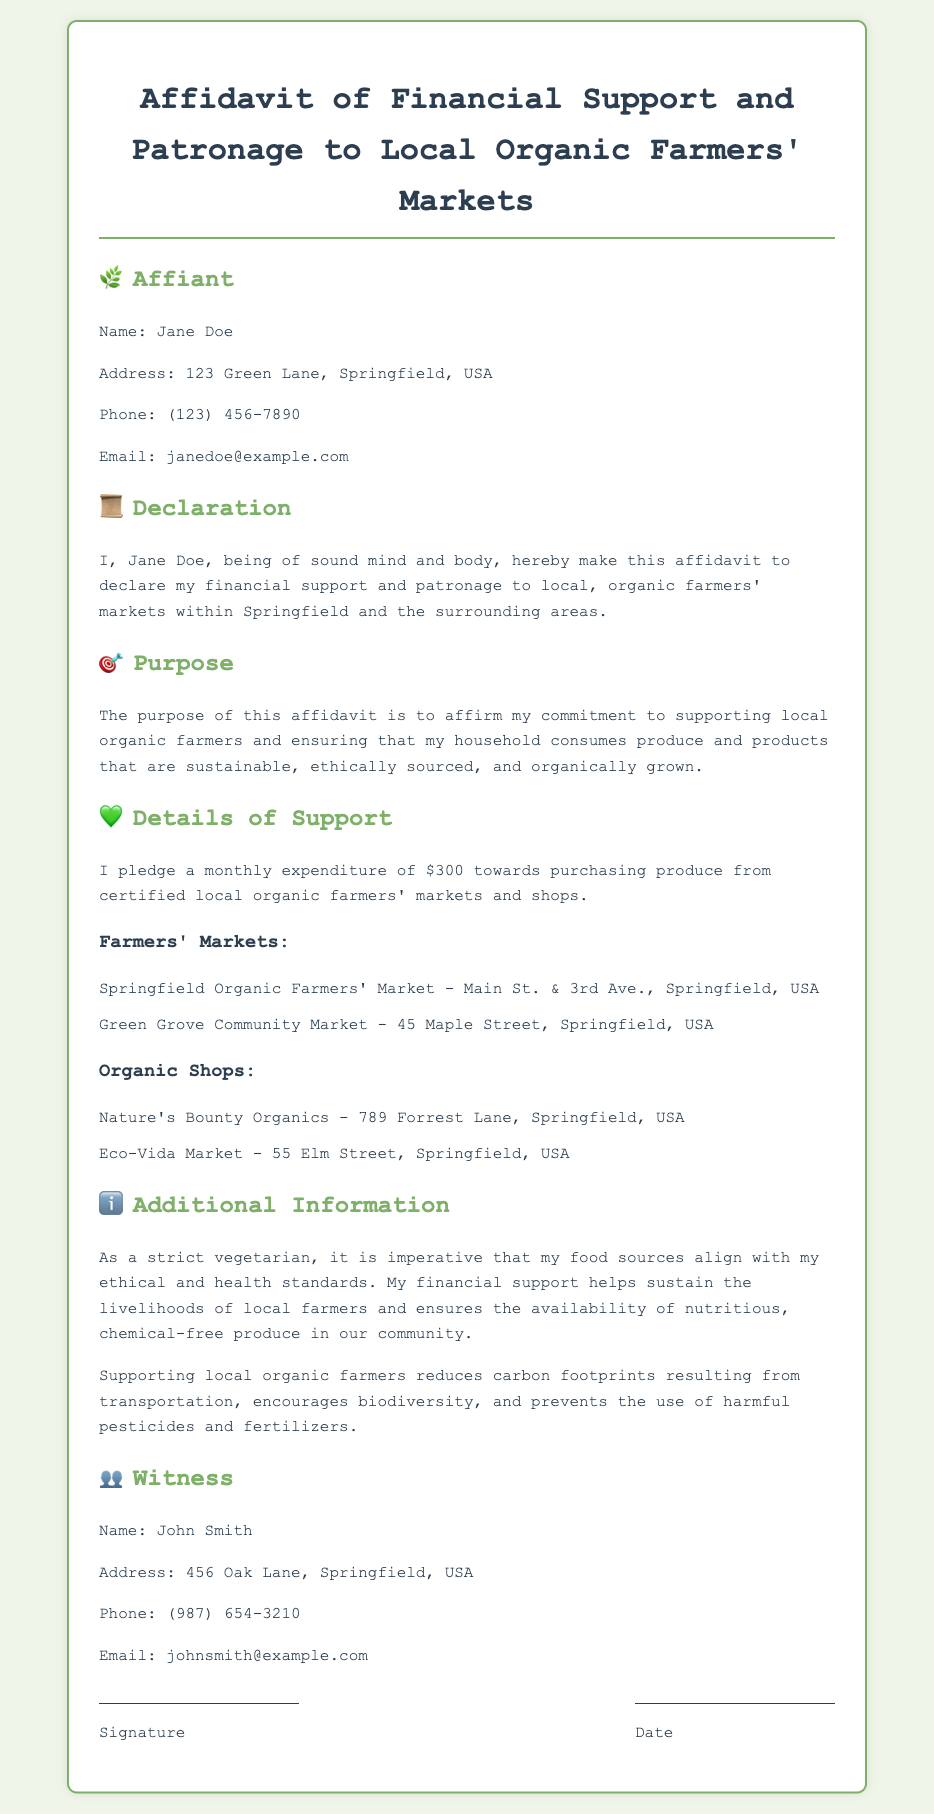What is the name of the affiant? The affiant's name is clearly stated in the document under the section titled "Affiant."
Answer: Jane Doe What is the monthly expenditure pledged by the affiant? The pledged monthly expenditure is highlighted in the "Details of Support" section of the affidavit.
Answer: $300 What are the addresses of the two farmers' markets listed? The addresses are mentioned in the "Farmers' Markets" subsection of the "Details of Support" section.
Answer: Main St. & 3rd Ave., 45 Maple Street What is the purpose of this affidavit? The purpose is outlined in a dedicated section, summarizing the affiant's commitment.
Answer: To affirm my commitment to supporting local organic farmers What is the phone number of the witness? The witness's phone number is provided in the "Witness" section of the document.
Answer: (987) 654-3210 How does the affiant view their food sources? This perspective is expressed in the "Additional Information" section regarding ethical and health standards.
Answer: Align with my ethical and health standards What kind of markets does the affiant support? The type of markets supported is described within the "Details of Support" section concerning their financial contributions.
Answer: Local organic farmers' markets Who is named as the witness in the document? The witness's name is presented under the "Witness" section.
Answer: John Smith 